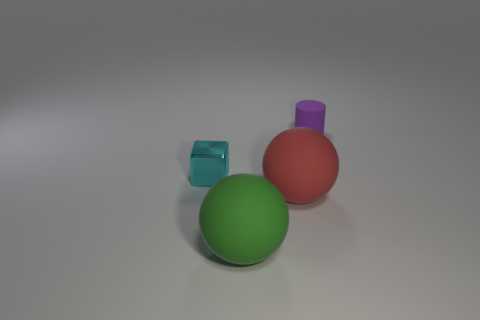Add 4 gray metallic balls. How many objects exist? 8 Subtract all cubes. How many objects are left? 3 Subtract 0 red cylinders. How many objects are left? 4 Subtract all rubber objects. Subtract all green things. How many objects are left? 0 Add 1 tiny cyan things. How many tiny cyan things are left? 2 Add 4 purple rubber things. How many purple rubber things exist? 5 